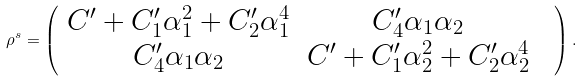Convert formula to latex. <formula><loc_0><loc_0><loc_500><loc_500>\rho ^ { s } = \left ( \begin{array} { c c c } C ^ { \prime } + C _ { 1 } ^ { \prime } \alpha _ { 1 } ^ { 2 } + C _ { 2 } ^ { \prime } \alpha _ { 1 } ^ { 4 } & C _ { 4 } ^ { \prime } \alpha _ { 1 } \alpha _ { 2 } & \\ C _ { 4 } ^ { \prime } \alpha _ { 1 } \alpha _ { 2 } & C ^ { \prime } + C _ { 1 } ^ { \prime } \alpha _ { 2 } ^ { 2 } + C _ { 2 } ^ { \prime } \alpha _ { 2 } ^ { 4 } \end{array} \right ) .</formula> 